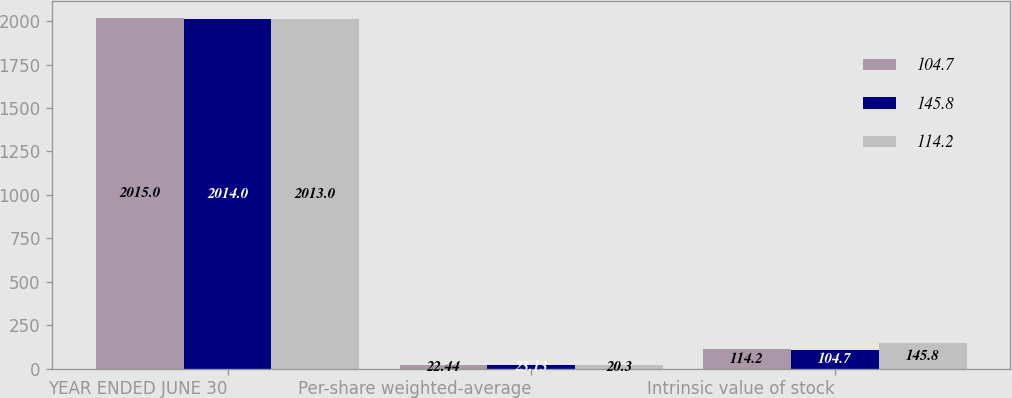Convert chart to OTSL. <chart><loc_0><loc_0><loc_500><loc_500><stacked_bar_chart><ecel><fcel>YEAR ENDED JUNE 30<fcel>Per-share weighted-average<fcel>Intrinsic value of stock<nl><fcel>104.7<fcel>2015<fcel>22.44<fcel>114.2<nl><fcel>145.8<fcel>2014<fcel>23.13<fcel>104.7<nl><fcel>114.2<fcel>2013<fcel>20.3<fcel>145.8<nl></chart> 